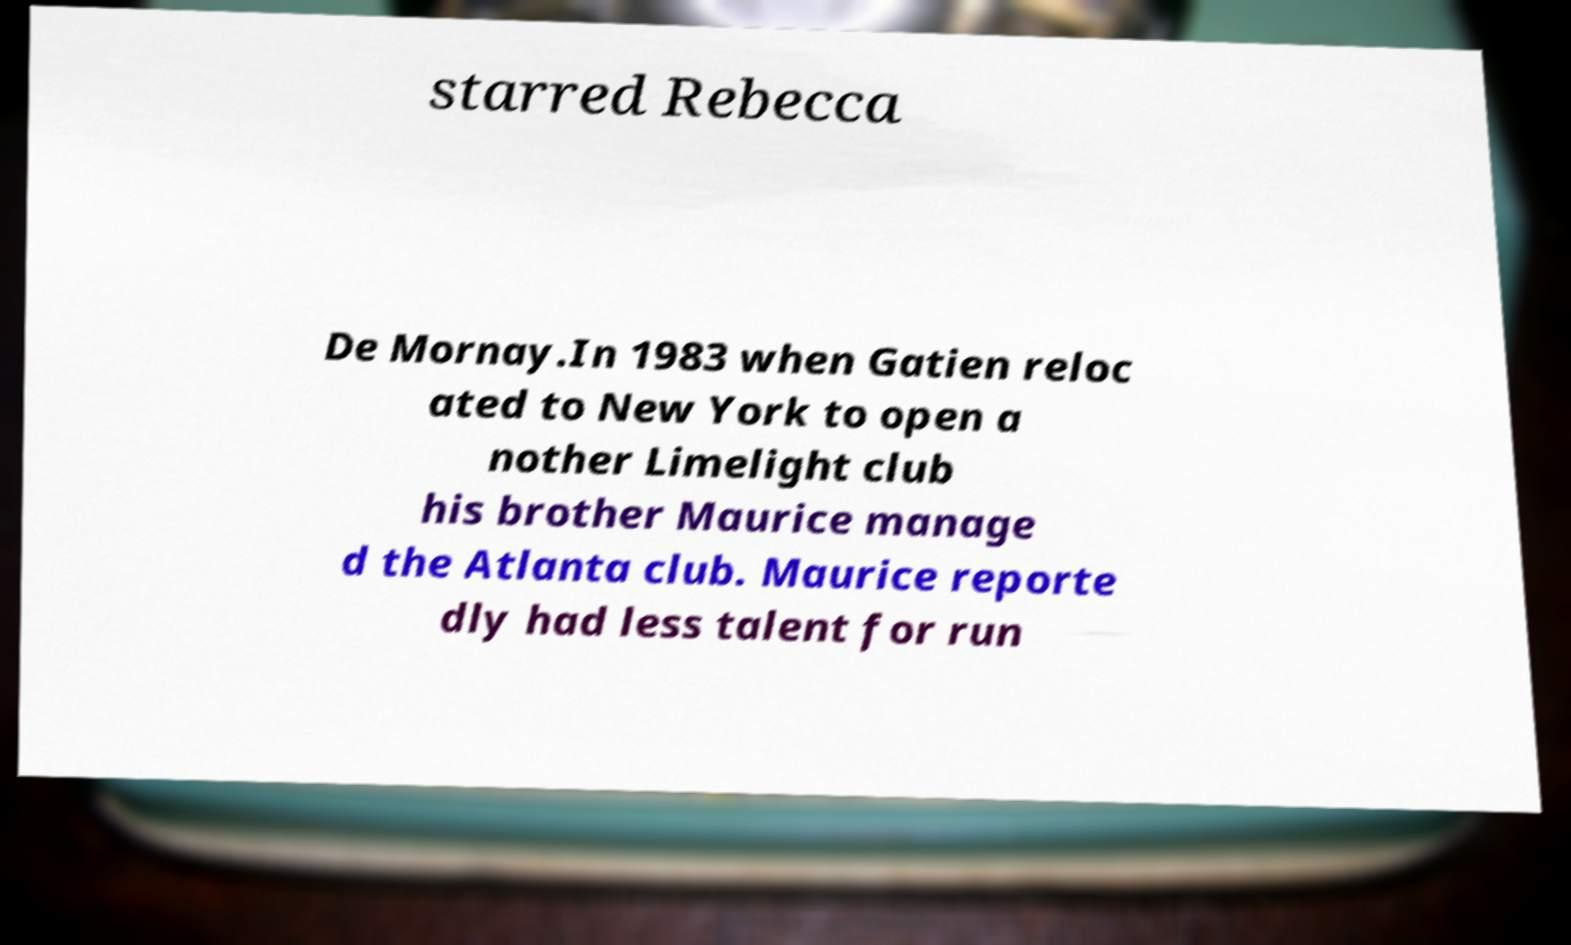Please read and relay the text visible in this image. What does it say? starred Rebecca De Mornay.In 1983 when Gatien reloc ated to New York to open a nother Limelight club his brother Maurice manage d the Atlanta club. Maurice reporte dly had less talent for run 